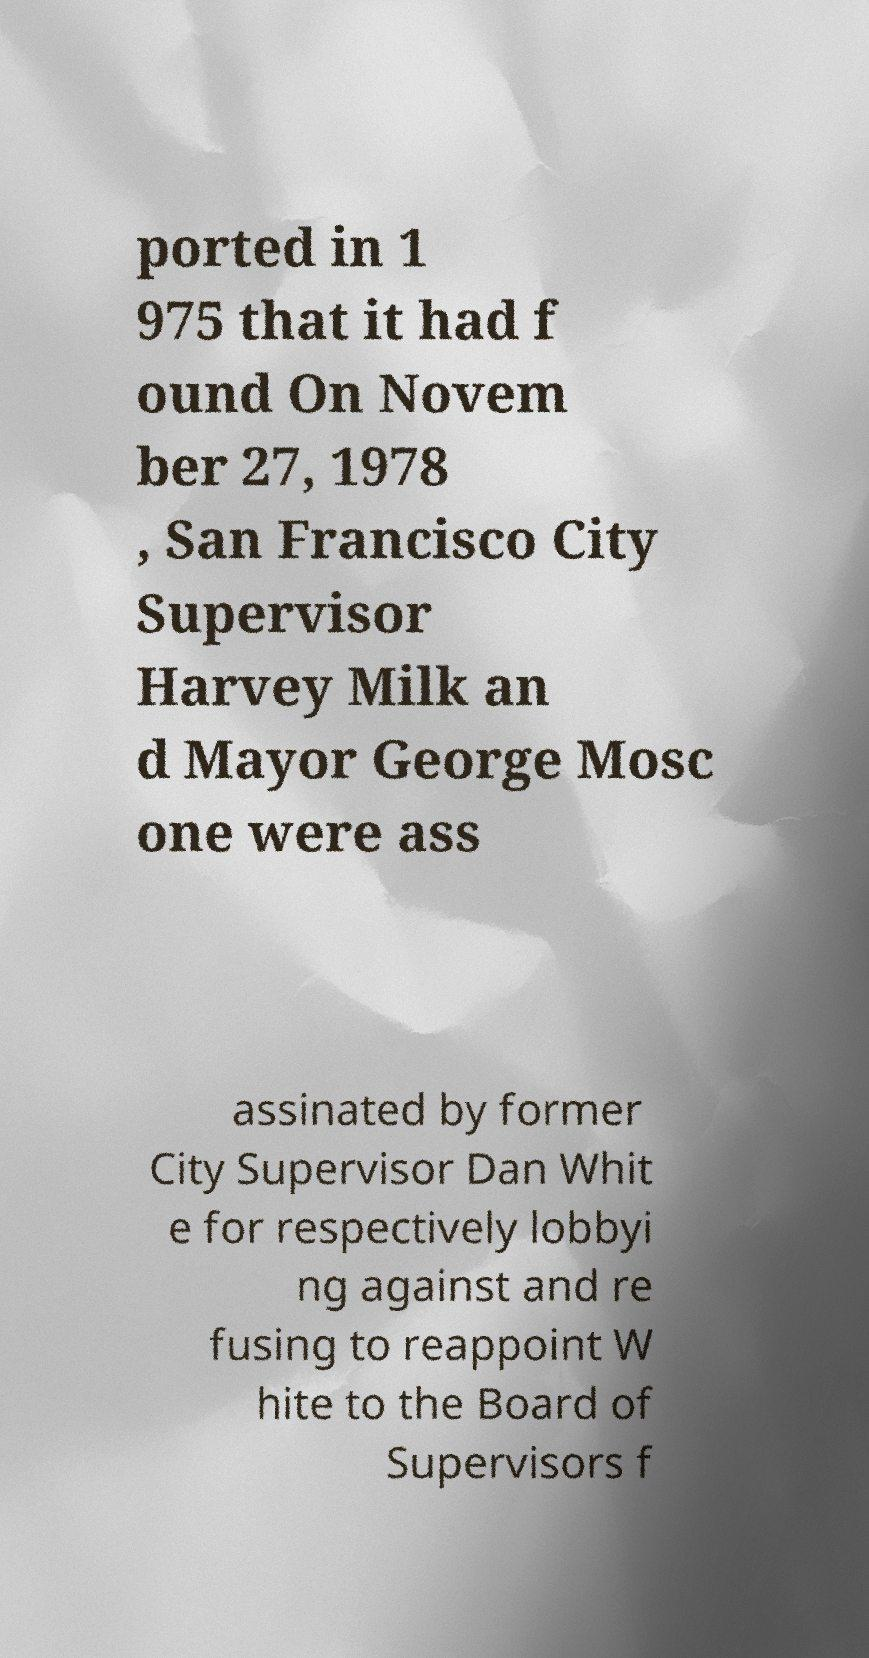Please read and relay the text visible in this image. What does it say? ported in 1 975 that it had f ound On Novem ber 27, 1978 , San Francisco City Supervisor Harvey Milk an d Mayor George Mosc one were ass assinated by former City Supervisor Dan Whit e for respectively lobbyi ng against and re fusing to reappoint W hite to the Board of Supervisors f 